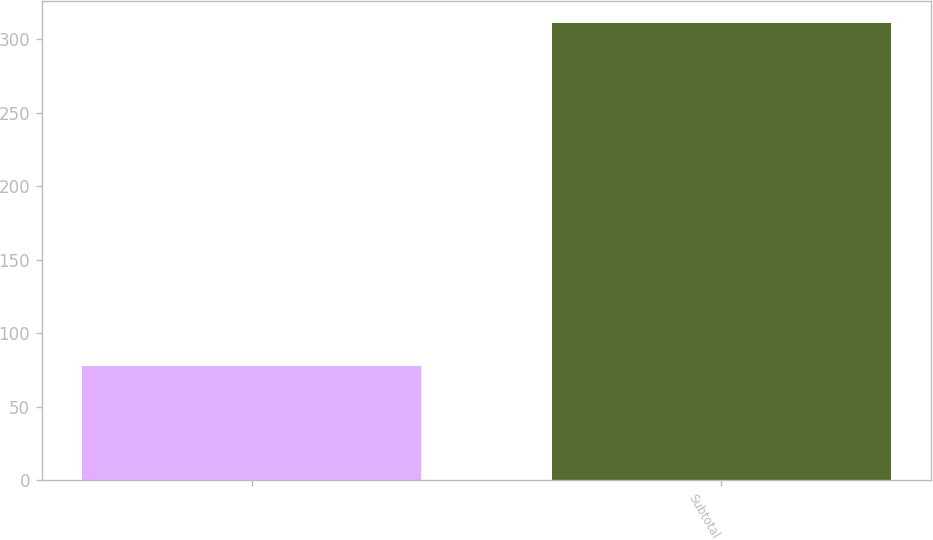Convert chart. <chart><loc_0><loc_0><loc_500><loc_500><bar_chart><ecel><fcel>Subtotal<nl><fcel>77.9<fcel>311<nl></chart> 